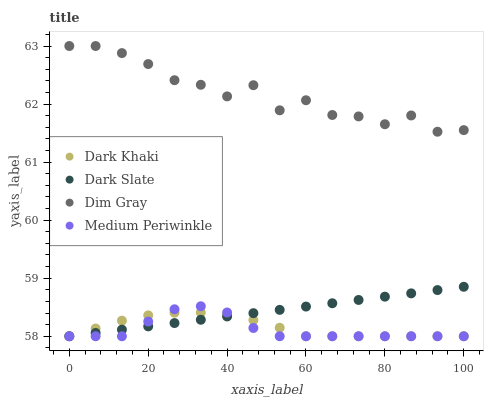Does Medium Periwinkle have the minimum area under the curve?
Answer yes or no. Yes. Does Dim Gray have the maximum area under the curve?
Answer yes or no. Yes. Does Dark Slate have the minimum area under the curve?
Answer yes or no. No. Does Dark Slate have the maximum area under the curve?
Answer yes or no. No. Is Dark Slate the smoothest?
Answer yes or no. Yes. Is Dim Gray the roughest?
Answer yes or no. Yes. Is Dim Gray the smoothest?
Answer yes or no. No. Is Dark Slate the roughest?
Answer yes or no. No. Does Dark Khaki have the lowest value?
Answer yes or no. Yes. Does Dim Gray have the lowest value?
Answer yes or no. No. Does Dim Gray have the highest value?
Answer yes or no. Yes. Does Dark Slate have the highest value?
Answer yes or no. No. Is Medium Periwinkle less than Dim Gray?
Answer yes or no. Yes. Is Dim Gray greater than Dark Khaki?
Answer yes or no. Yes. Does Dark Slate intersect Medium Periwinkle?
Answer yes or no. Yes. Is Dark Slate less than Medium Periwinkle?
Answer yes or no. No. Is Dark Slate greater than Medium Periwinkle?
Answer yes or no. No. Does Medium Periwinkle intersect Dim Gray?
Answer yes or no. No. 